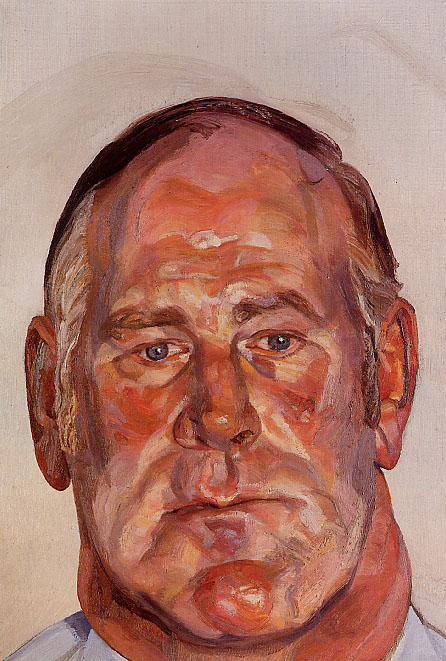If this painting could tell a story, what would it be? The painting could tell the story of a man navigating the complexities of his life. Perhaps he has lived through significant experiences—joy, sorrow, triumph, and loss—which have all contributed to the depth of his character. The warm, vivid colors could represent the various emotions he has felt, while his serene expression indicates a moment of quiet reflection. His story is one of resilience and contemplation, captured at a poignant moment where he is entirely within himself, detached from the outside world. 